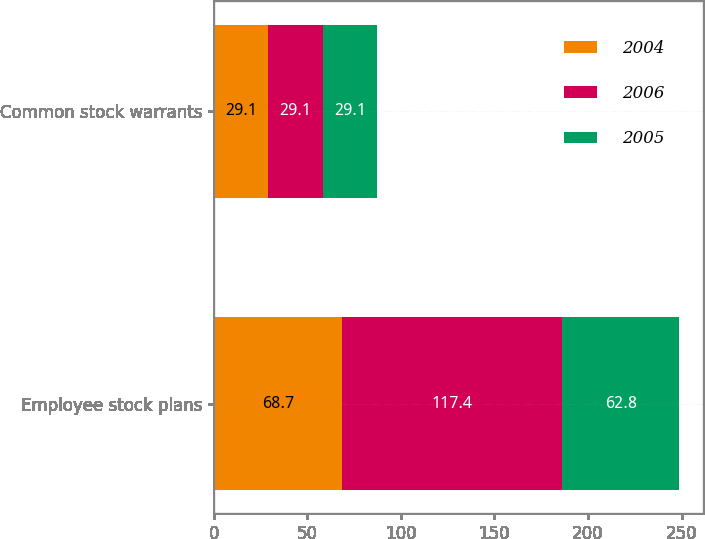Convert chart. <chart><loc_0><loc_0><loc_500><loc_500><stacked_bar_chart><ecel><fcel>Employee stock plans<fcel>Common stock warrants<nl><fcel>2004<fcel>68.7<fcel>29.1<nl><fcel>2006<fcel>117.4<fcel>29.1<nl><fcel>2005<fcel>62.8<fcel>29.1<nl></chart> 